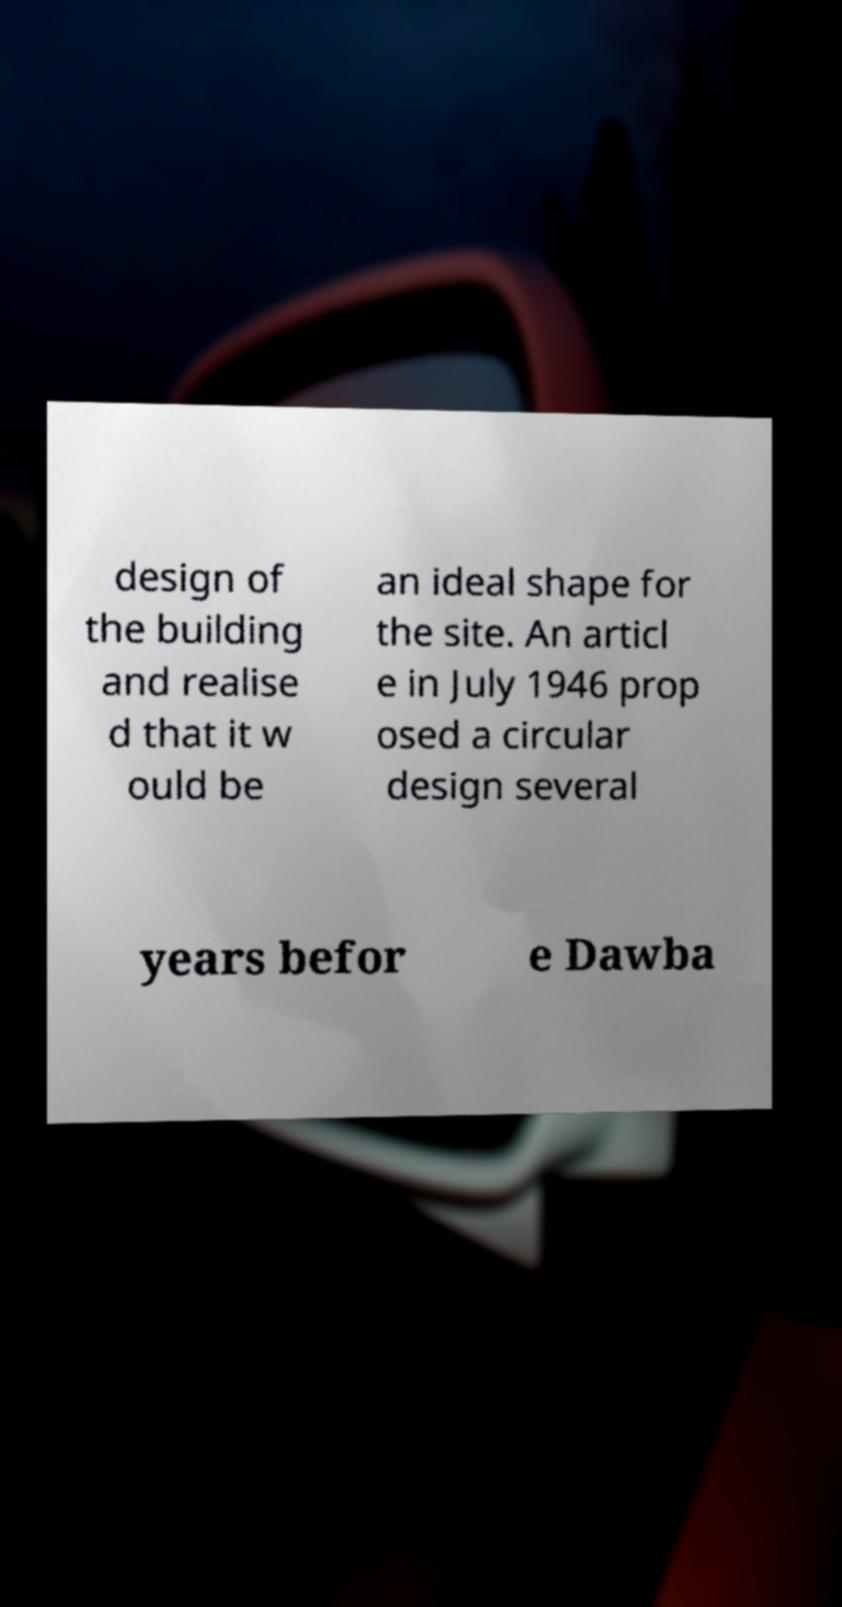For documentation purposes, I need the text within this image transcribed. Could you provide that? design of the building and realise d that it w ould be an ideal shape for the site. An articl e in July 1946 prop osed a circular design several years befor e Dawba 